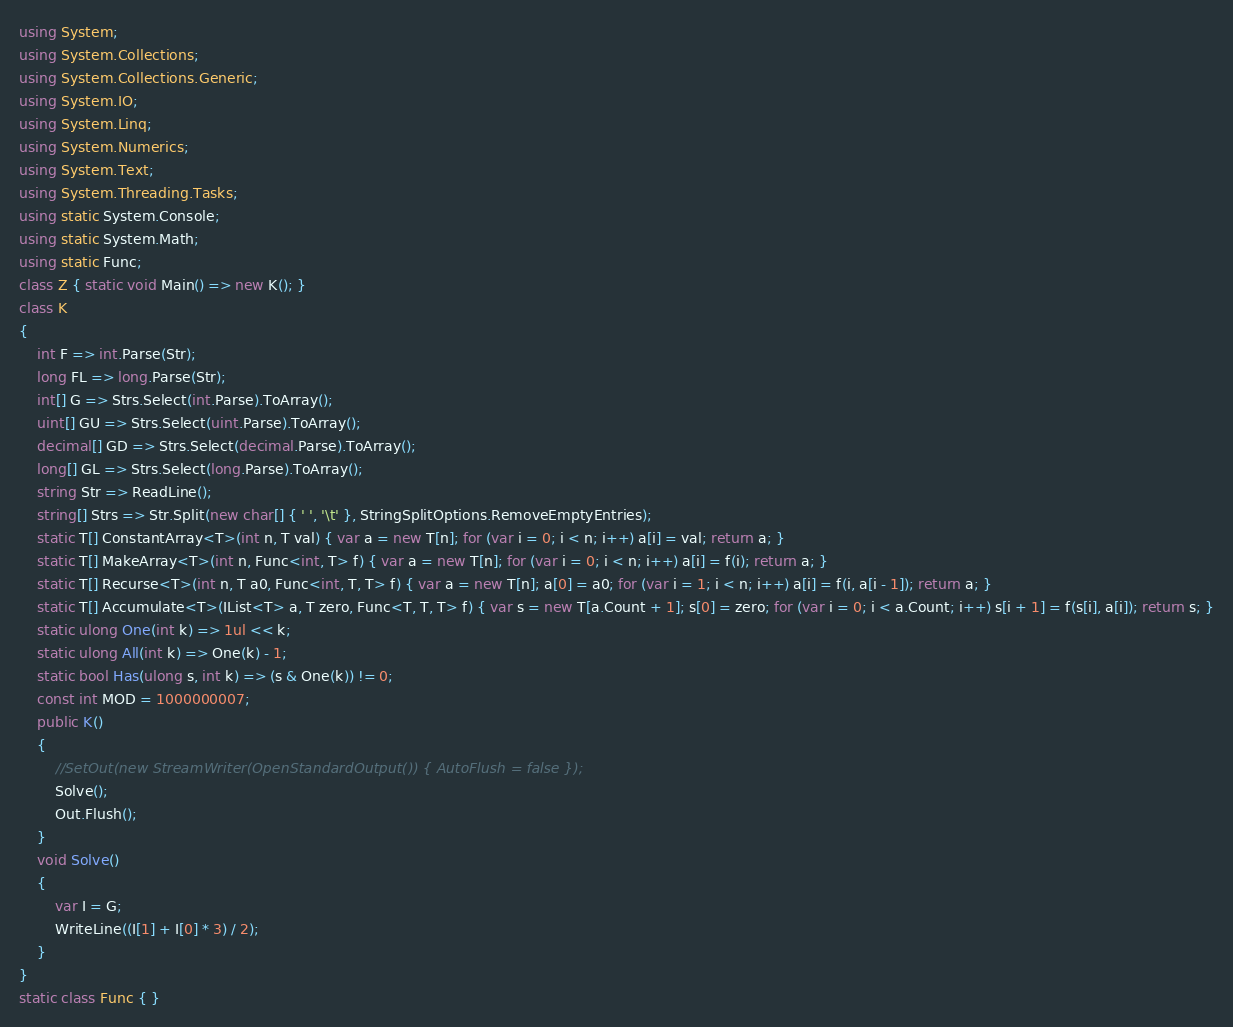Convert code to text. <code><loc_0><loc_0><loc_500><loc_500><_C#_>using System;
using System.Collections;
using System.Collections.Generic;
using System.IO;
using System.Linq;
using System.Numerics;
using System.Text;
using System.Threading.Tasks;
using static System.Console;
using static System.Math;
using static Func;
class Z { static void Main() => new K(); }
class K
{
	int F => int.Parse(Str);
	long FL => long.Parse(Str);
	int[] G => Strs.Select(int.Parse).ToArray();
	uint[] GU => Strs.Select(uint.Parse).ToArray();
	decimal[] GD => Strs.Select(decimal.Parse).ToArray();
	long[] GL => Strs.Select(long.Parse).ToArray();
	string Str => ReadLine();
	string[] Strs => Str.Split(new char[] { ' ', '\t' }, StringSplitOptions.RemoveEmptyEntries);
	static T[] ConstantArray<T>(int n, T val) { var a = new T[n]; for (var i = 0; i < n; i++) a[i] = val; return a; }
	static T[] MakeArray<T>(int n, Func<int, T> f) { var a = new T[n]; for (var i = 0; i < n; i++) a[i] = f(i); return a; }
	static T[] Recurse<T>(int n, T a0, Func<int, T, T> f) { var a = new T[n]; a[0] = a0; for (var i = 1; i < n; i++) a[i] = f(i, a[i - 1]); return a; }
	static T[] Accumulate<T>(IList<T> a, T zero, Func<T, T, T> f) { var s = new T[a.Count + 1]; s[0] = zero; for (var i = 0; i < a.Count; i++) s[i + 1] = f(s[i], a[i]); return s; }
	static ulong One(int k) => 1ul << k;
	static ulong All(int k) => One(k) - 1;
	static bool Has(ulong s, int k) => (s & One(k)) != 0;
	const int MOD = 1000000007;
	public K()
	{
		//SetOut(new StreamWriter(OpenStandardOutput()) { AutoFlush = false });
		Solve();
		Out.Flush();
	}
	void Solve()
	{
		var I = G;
		WriteLine((I[1] + I[0] * 3) / 2);
	}
}
static class Func { }
</code> 